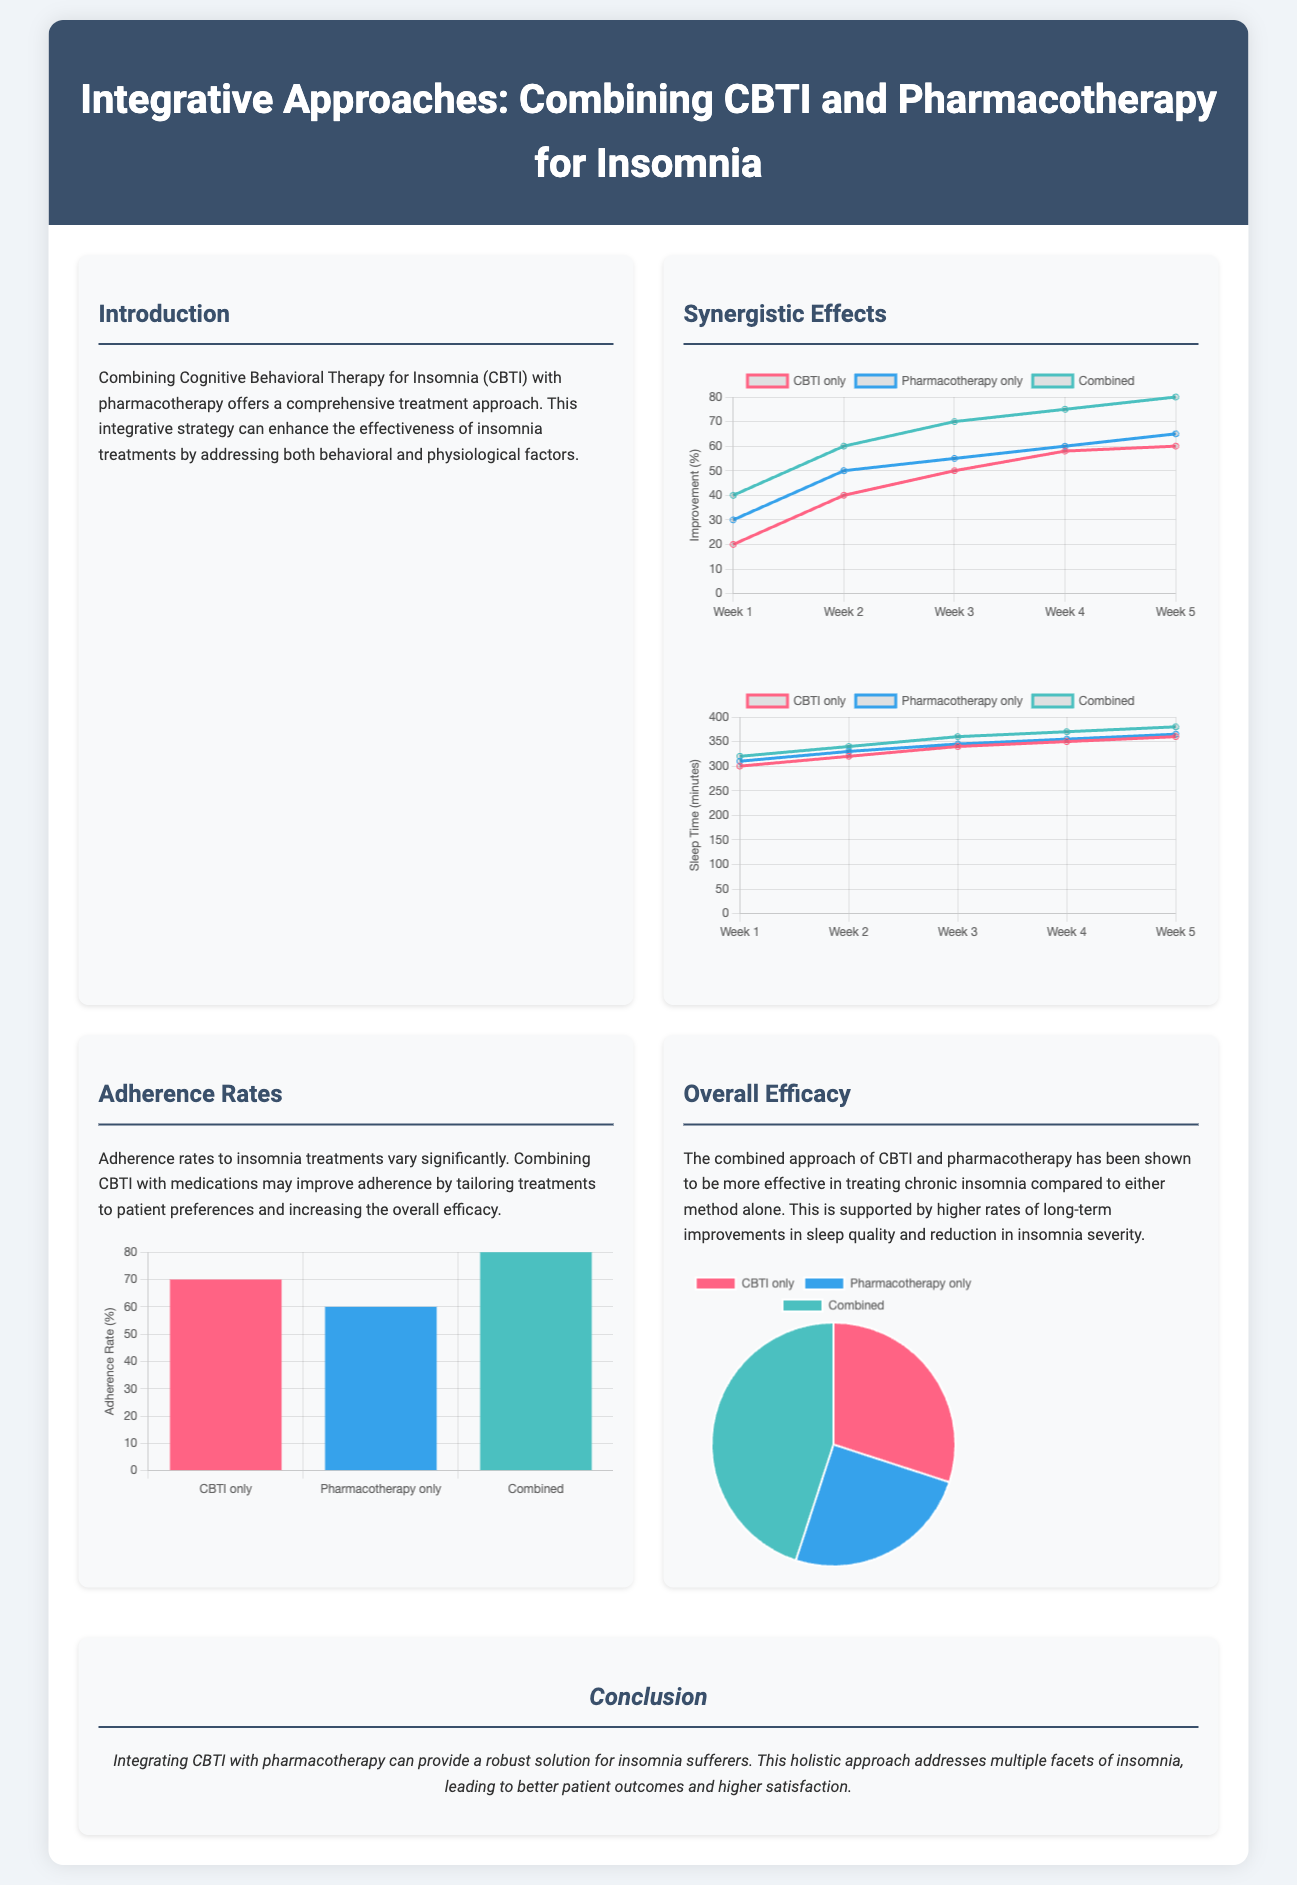what is the title of the document? The title can be found at the top of the document under the header section.
Answer: Integrative Approaches: Combining CBTI and Pharmacotherapy for Insomnia what is the main focus area of this infographic? The introduction section highlights the comprehensive treatment approach for insomnia.
Answer: Combining CBTI with pharmacotherapy what was the improvement in Sleep Onset Latency for Combined therapy in Week 5? This information is retrieved from the Sleep Onset Latency chart.
Answer: 80 what percentage of adherence was reported for Pharmacotherapy only? The adherence rates are shown in the Adherence Rates chart.
Answer: 60 what is the efficacy percentage for the Combined approach? This statistic is indicated in the Overall Efficacy chart.
Answer: 45 what type of chart is used to display Adherence Rates? The type of chart is stated in the chart description.
Answer: Bar which intervention shows the highest improvement in Total Sleep Time after 5 weeks? An analysis of the Total Sleep Time chart reveals this information.
Answer: Combined what is the improvement in Total Sleep Time for CBTI only by Week 5? This data is collected from the Total Sleep Time chart.
Answer: 360 what is the color representing Pharmacotherapy only in the Sleep Onset Latency chart? The color coding is specified in the chart legend.
Answer: Blue 